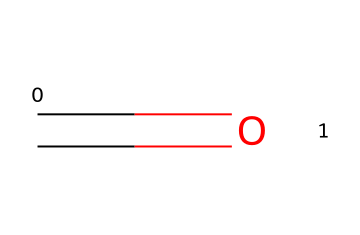What is the name of this chemical? The SMILES representation "C=O" indicates that the molecule consists of a carbon atom double-bonded to an oxygen atom, which is the defining feature of formaldehyde.
Answer: formaldehyde How many atoms are present in this chemical? The SMILES representation shows two distinct atoms: one carbon (C) and one oxygen (O) atom. Thus, there are 2 atoms in total.
Answer: 2 What type of bond is present between carbon and oxygen in this chemical? The notation "C=O" shows that there is a double bond between the carbon and oxygen atoms, which is a specific type of covalent bond.
Answer: double bond Is this chemical classified as a hazardous chemical? Formaldehyde is a well-known hazardous chemical due to its toxicity and potential health effects, confirming its classification.
Answer: yes What functional group does this chemical belong to? The structure "C=O" represents the carbonyl group, which is characteristic of aldehydes and ketones. Therefore, formaldehyde belongs to the aldehyde functional group.
Answer: aldehyde What is the molecular formula of this chemical? The chemical structure corresponds to one carbon and one oxygen atom, leading to the molecular formula CH2O, which is derived by balancing the hydrogens in aldehydes.
Answer: CH2O 